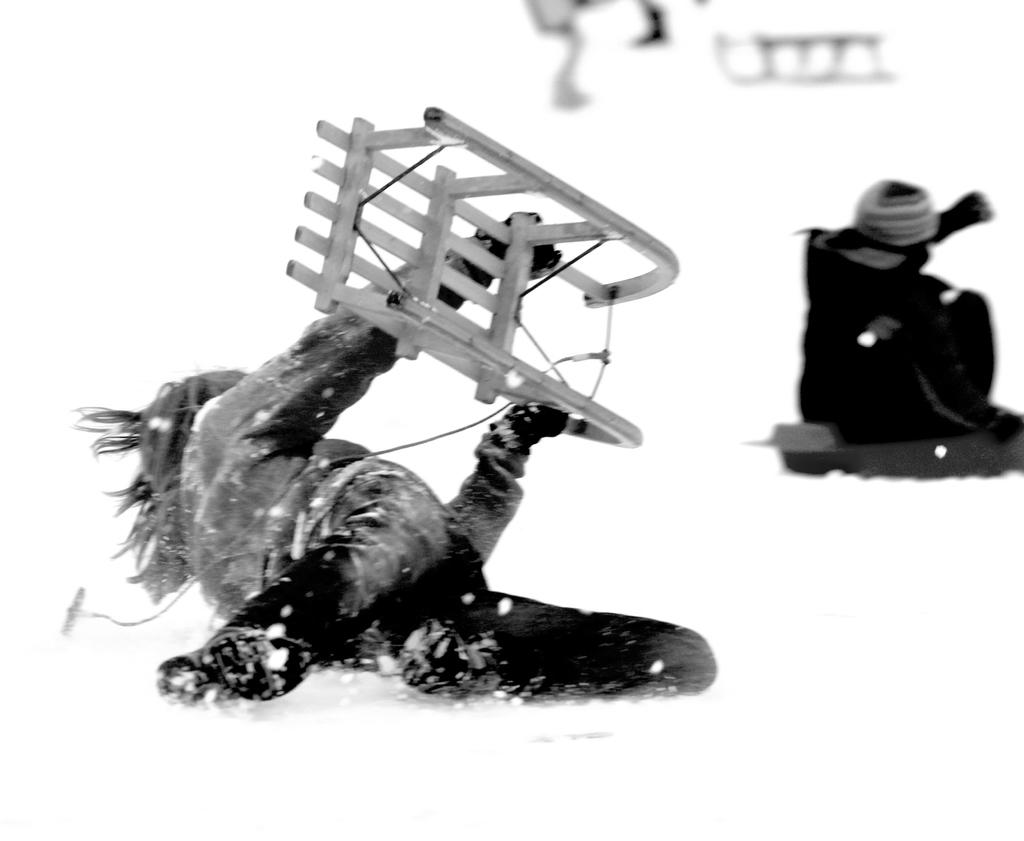What is the color scheme of the image? The image is black and white. How many people are in the image? There are a few people in the image. What is one person doing in the image? One person is holding an object. What type of weather is depicted in the image? There is snow visible in the image. What type of patch is being sewn onto the person's clothing in the image? There is no patch or sewing activity depicted in the image; it is black and white with a few people and snow. What type of stove is being used to cook food in the image? There is no stove or cooking activity depicted in the image; it is black and white with a few people and snow. 